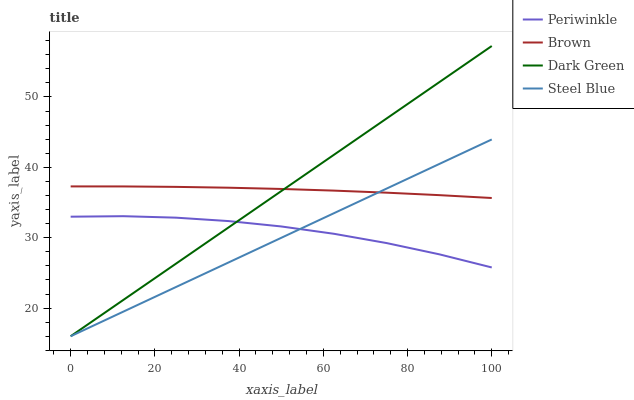Does Steel Blue have the minimum area under the curve?
Answer yes or no. Yes. Does Brown have the maximum area under the curve?
Answer yes or no. Yes. Does Periwinkle have the minimum area under the curve?
Answer yes or no. No. Does Periwinkle have the maximum area under the curve?
Answer yes or no. No. Is Dark Green the smoothest?
Answer yes or no. Yes. Is Periwinkle the roughest?
Answer yes or no. Yes. Is Steel Blue the smoothest?
Answer yes or no. No. Is Steel Blue the roughest?
Answer yes or no. No. Does Steel Blue have the lowest value?
Answer yes or no. Yes. Does Periwinkle have the lowest value?
Answer yes or no. No. Does Dark Green have the highest value?
Answer yes or no. Yes. Does Steel Blue have the highest value?
Answer yes or no. No. Is Periwinkle less than Brown?
Answer yes or no. Yes. Is Brown greater than Periwinkle?
Answer yes or no. Yes. Does Dark Green intersect Periwinkle?
Answer yes or no. Yes. Is Dark Green less than Periwinkle?
Answer yes or no. No. Is Dark Green greater than Periwinkle?
Answer yes or no. No. Does Periwinkle intersect Brown?
Answer yes or no. No. 